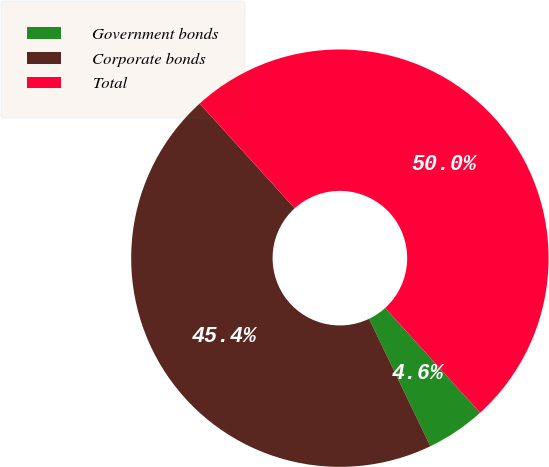Convert chart to OTSL. <chart><loc_0><loc_0><loc_500><loc_500><pie_chart><fcel>Government bonds<fcel>Corporate bonds<fcel>Total<nl><fcel>4.59%<fcel>45.41%<fcel>50.0%<nl></chart> 